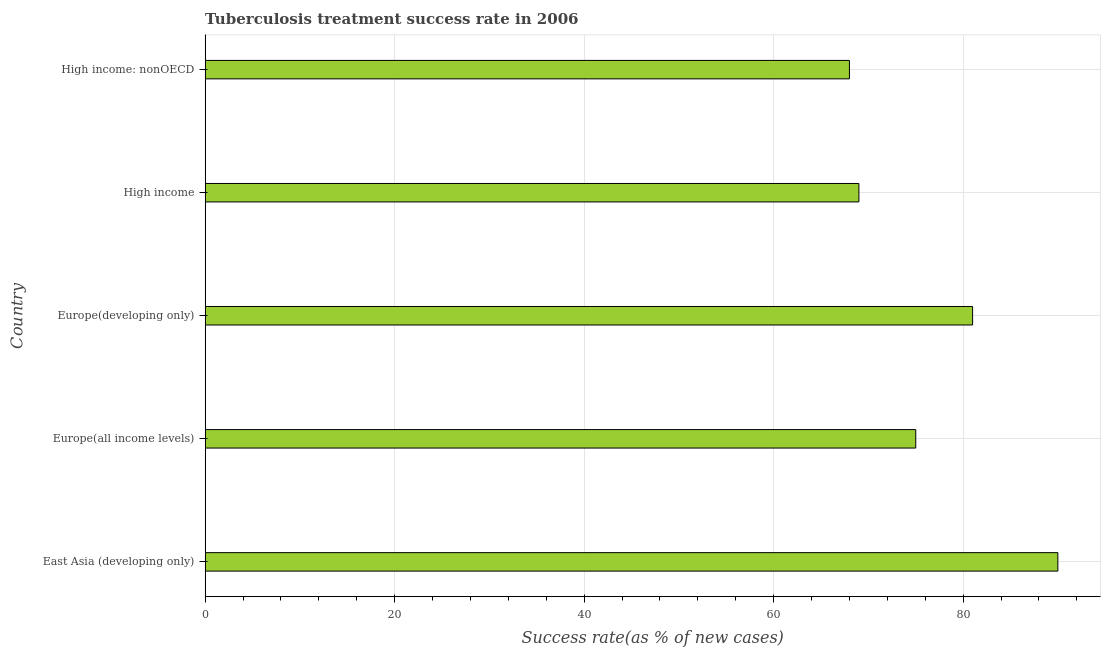Does the graph contain any zero values?
Your response must be concise. No. What is the title of the graph?
Keep it short and to the point. Tuberculosis treatment success rate in 2006. What is the label or title of the X-axis?
Your answer should be compact. Success rate(as % of new cases). What is the label or title of the Y-axis?
Your answer should be very brief. Country. In which country was the tuberculosis treatment success rate maximum?
Your response must be concise. East Asia (developing only). In which country was the tuberculosis treatment success rate minimum?
Keep it short and to the point. High income: nonOECD. What is the sum of the tuberculosis treatment success rate?
Keep it short and to the point. 383. What is the difference between the tuberculosis treatment success rate in East Asia (developing only) and Europe(developing only)?
Provide a succinct answer. 9. What is the average tuberculosis treatment success rate per country?
Provide a succinct answer. 76. In how many countries, is the tuberculosis treatment success rate greater than 88 %?
Offer a very short reply. 1. What is the ratio of the tuberculosis treatment success rate in Europe(developing only) to that in High income: nonOECD?
Your response must be concise. 1.19. Is the difference between the tuberculosis treatment success rate in Europe(developing only) and High income greater than the difference between any two countries?
Keep it short and to the point. No. What is the difference between the highest and the second highest tuberculosis treatment success rate?
Provide a succinct answer. 9. In how many countries, is the tuberculosis treatment success rate greater than the average tuberculosis treatment success rate taken over all countries?
Provide a succinct answer. 2. How many countries are there in the graph?
Provide a short and direct response. 5. What is the difference between two consecutive major ticks on the X-axis?
Provide a succinct answer. 20. Are the values on the major ticks of X-axis written in scientific E-notation?
Your response must be concise. No. What is the Success rate(as % of new cases) of Europe(all income levels)?
Offer a terse response. 75. What is the Success rate(as % of new cases) of High income: nonOECD?
Provide a short and direct response. 68. What is the difference between the Success rate(as % of new cases) in East Asia (developing only) and Europe(all income levels)?
Offer a terse response. 15. What is the difference between the Success rate(as % of new cases) in East Asia (developing only) and Europe(developing only)?
Provide a succinct answer. 9. What is the difference between the Success rate(as % of new cases) in East Asia (developing only) and High income: nonOECD?
Keep it short and to the point. 22. What is the difference between the Success rate(as % of new cases) in Europe(all income levels) and Europe(developing only)?
Provide a short and direct response. -6. What is the difference between the Success rate(as % of new cases) in Europe(all income levels) and High income?
Your response must be concise. 6. What is the difference between the Success rate(as % of new cases) in Europe(all income levels) and High income: nonOECD?
Your response must be concise. 7. What is the difference between the Success rate(as % of new cases) in Europe(developing only) and High income?
Give a very brief answer. 12. What is the ratio of the Success rate(as % of new cases) in East Asia (developing only) to that in Europe(all income levels)?
Provide a short and direct response. 1.2. What is the ratio of the Success rate(as % of new cases) in East Asia (developing only) to that in Europe(developing only)?
Your answer should be very brief. 1.11. What is the ratio of the Success rate(as % of new cases) in East Asia (developing only) to that in High income?
Make the answer very short. 1.3. What is the ratio of the Success rate(as % of new cases) in East Asia (developing only) to that in High income: nonOECD?
Offer a terse response. 1.32. What is the ratio of the Success rate(as % of new cases) in Europe(all income levels) to that in Europe(developing only)?
Your response must be concise. 0.93. What is the ratio of the Success rate(as % of new cases) in Europe(all income levels) to that in High income?
Your answer should be compact. 1.09. What is the ratio of the Success rate(as % of new cases) in Europe(all income levels) to that in High income: nonOECD?
Give a very brief answer. 1.1. What is the ratio of the Success rate(as % of new cases) in Europe(developing only) to that in High income?
Offer a terse response. 1.17. What is the ratio of the Success rate(as % of new cases) in Europe(developing only) to that in High income: nonOECD?
Give a very brief answer. 1.19. 